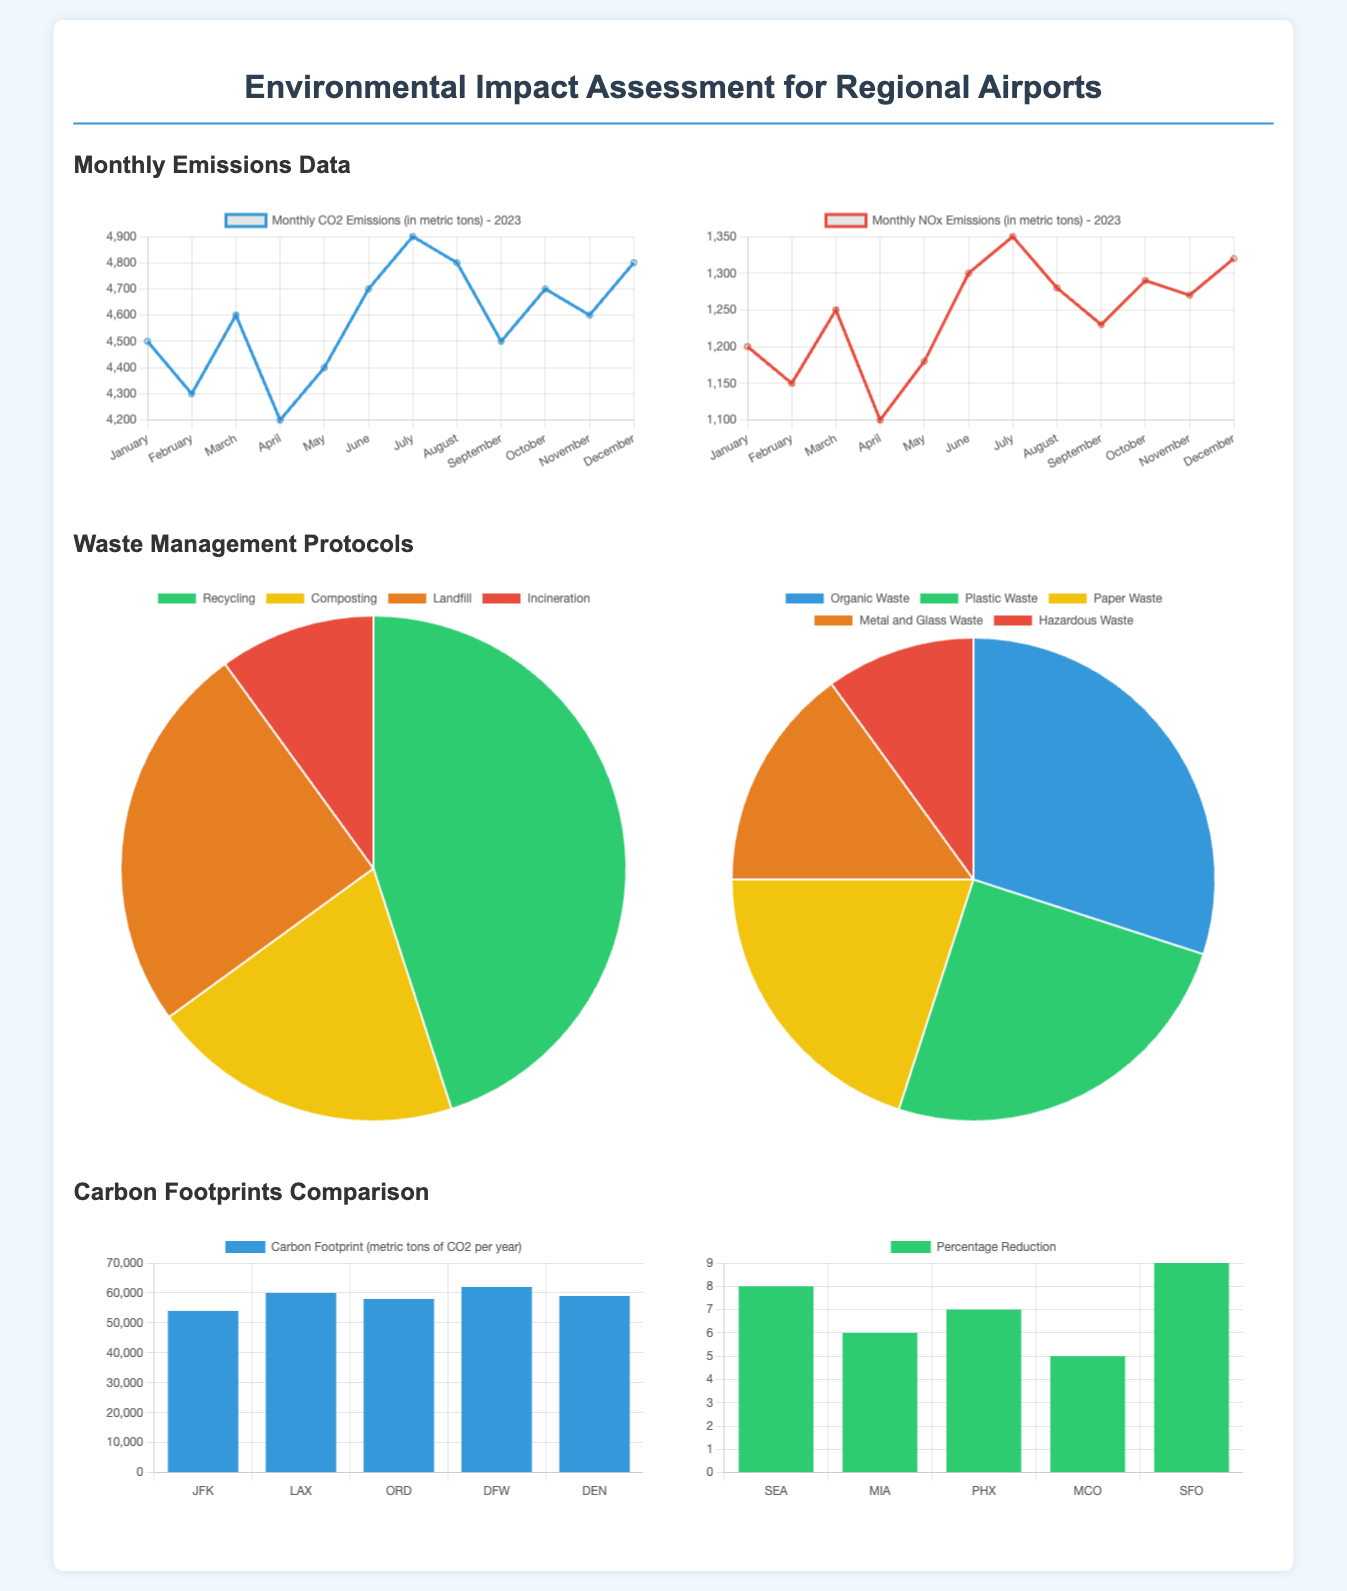What is the total CO2 emissions in May? The total CO2 emissions in May is shown as a data point in the chart, which lists May's value as 4400 metric tons.
Answer: 4400 metric tons Which waste management protocol has the highest distribution? The waste management protocols are represented in a pie chart, showing that Recycling has the highest percentage at 45%.
Answer: Recycling What is the highest NOx emissions recorded in July? The NOx emissions data for July shows the figure as 1350 metric tons, the highest value in that month.
Answer: 1350 metric tons How many different types of waste are represented in the waste types chart? The waste types chart lists five categories: Organic, Plastic, Paper, Metal and Glass, and Hazardous Waste, totaling five.
Answer: 5 Which airport has the largest carbon footprint? The carbon footprint bar chart indicates that DFW has the largest carbon footprint at 62000 metric tons of CO2 per year.
Answer: DFW What percentage reduction in carbon footprints does SFO achieve from 2022 to 2023? The percentage reduction bar chart specifies that SFO achieved a reduction of 9%.
Answer: 9% What month has the lowest CO2 emissions? The monthly CO2 emissions line chart indicates that February has the lowest recorded emissions of 4300 metric tons.
Answer: February What is the total amount of organic waste generated? As depicted in the waste types pie chart, organic waste accounts for 30% of the total waste generated at regional airports.
Answer: 30% 